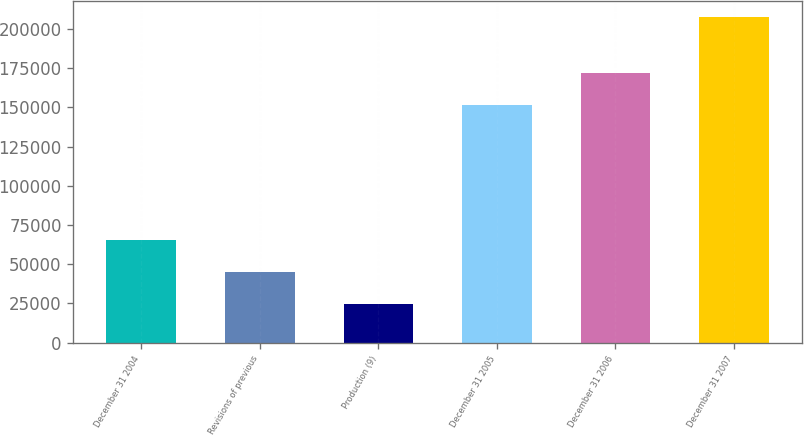Convert chart to OTSL. <chart><loc_0><loc_0><loc_500><loc_500><bar_chart><fcel>December 31 2004<fcel>Revisions of previous<fcel>Production (9)<fcel>December 31 2005<fcel>December 31 2006<fcel>December 31 2007<nl><fcel>65160.4<fcel>44837.6<fcel>24514.8<fcel>151656<fcel>171979<fcel>207420<nl></chart> 